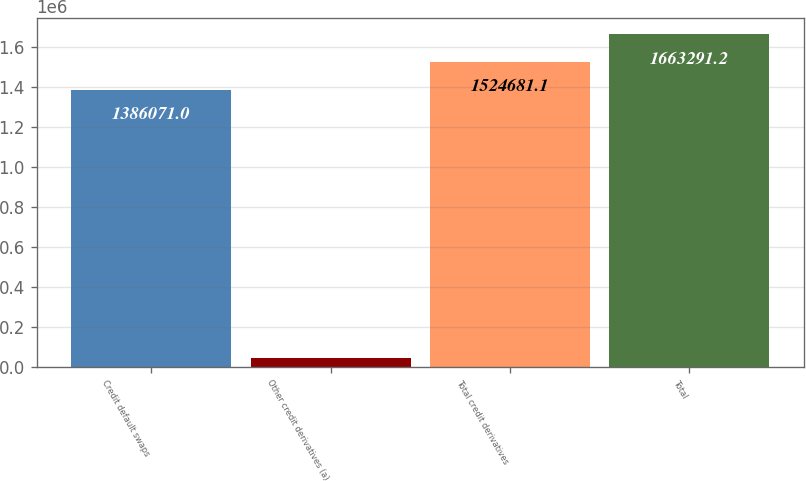Convert chart. <chart><loc_0><loc_0><loc_500><loc_500><bar_chart><fcel>Credit default swaps<fcel>Other credit derivatives (a)<fcel>Total credit derivatives<fcel>Total<nl><fcel>1.38607e+06<fcel>42738<fcel>1.52468e+06<fcel>1.66329e+06<nl></chart> 